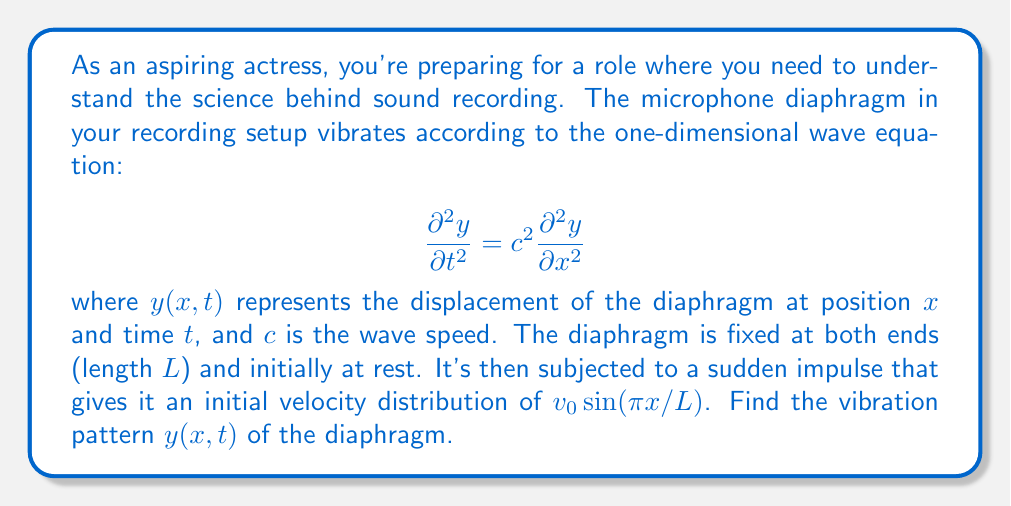Solve this math problem. Let's solve this step-by-step:

1) The general solution to the wave equation with fixed ends is:

   $$y(x,t) = \sum_{n=1}^{\infty} (A_n \cos(n\pi ct/L) + B_n \sin(n\pi ct/L)) \sin(n\pi x/L)$$

2) Given initial conditions:
   $y(x,0) = 0$ (initially at rest)
   $\frac{\partial y}{\partial t}(x,0) = v_0 \sin(\pi x/L)$ (initial velocity distribution)

3) The first condition gives us:
   $y(x,0) = \sum_{n=1}^{\infty} A_n \sin(n\pi x/L) = 0$
   Therefore, $A_n = 0$ for all $n$

4) The second condition:
   $\frac{\partial y}{\partial t}(x,0) = \sum_{n=1}^{\infty} B_n \frac{n\pi c}{L} \sin(n\pi x/L) = v_0 \sin(\pi x/L)$

5) Comparing coefficients, we see that $B_n = 0$ for all $n \neq 1$, and:
   $B_1 \frac{\pi c}{L} = v_0$
   $B_1 = \frac{v_0 L}{\pi c}$

6) Therefore, the vibration pattern is:

   $$y(x,t) = \frac{v_0 L}{\pi c} \sin(\pi ct/L) \sin(\pi x/L)$$

This represents a standing wave with a single mode of vibration.
Answer: $$y(x,t) = \frac{v_0 L}{\pi c} \sin(\pi ct/L) \sin(\pi x/L)$$ 